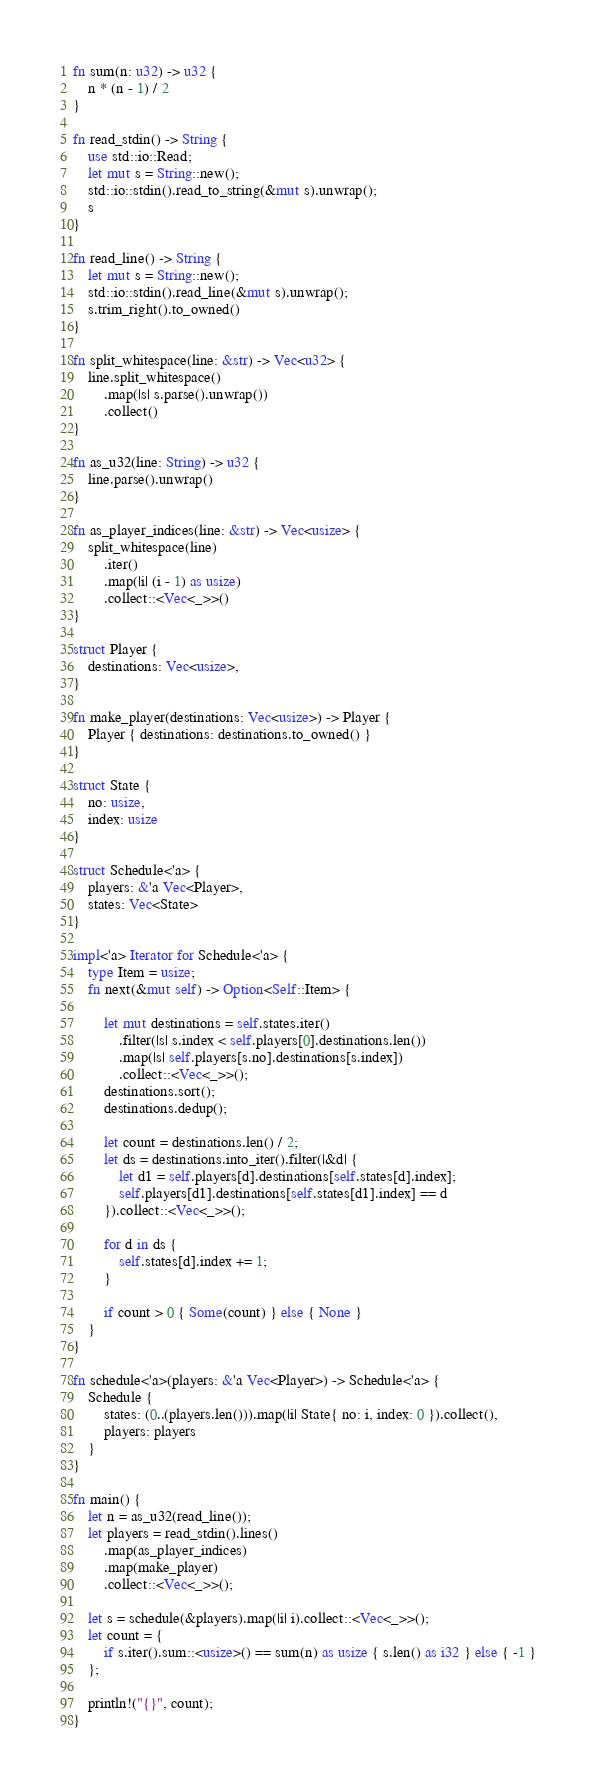<code> <loc_0><loc_0><loc_500><loc_500><_Rust_>fn sum(n: u32) -> u32 {
    n * (n - 1) / 2
}

fn read_stdin() -> String {
    use std::io::Read;
    let mut s = String::new();
    std::io::stdin().read_to_string(&mut s).unwrap();
    s
}

fn read_line() -> String {
    let mut s = String::new();
    std::io::stdin().read_line(&mut s).unwrap();
    s.trim_right().to_owned()
}

fn split_whitespace(line: &str) -> Vec<u32> {
    line.split_whitespace()
        .map(|s| s.parse().unwrap())
        .collect()
}

fn as_u32(line: String) -> u32 {
    line.parse().unwrap()
}

fn as_player_indices(line: &str) -> Vec<usize> {
    split_whitespace(line)
        .iter()
        .map(|i| (i - 1) as usize)
        .collect::<Vec<_>>()
}

struct Player {
    destinations: Vec<usize>,
}

fn make_player(destinations: Vec<usize>) -> Player {
    Player { destinations: destinations.to_owned() }
}

struct State {
    no: usize,
    index: usize
}

struct Schedule<'a> {
    players: &'a Vec<Player>,
    states: Vec<State>
}

impl<'a> Iterator for Schedule<'a> {
    type Item = usize;
    fn next(&mut self) -> Option<Self::Item> {
        
        let mut destinations = self.states.iter()
            .filter(|s| s.index < self.players[0].destinations.len())
            .map(|s| self.players[s.no].destinations[s.index])
            .collect::<Vec<_>>();
        destinations.sort();
        destinations.dedup();
            
        let count = destinations.len() / 2;
        let ds = destinations.into_iter().filter(|&d| {
            let d1 = self.players[d].destinations[self.states[d].index];
            self.players[d1].destinations[self.states[d1].index] == d
        }).collect::<Vec<_>>();
        
        for d in ds {
            self.states[d].index += 1;
        }
        
        if count > 0 { Some(count) } else { None }
    }
}

fn schedule<'a>(players: &'a Vec<Player>) -> Schedule<'a> {
    Schedule {
        states: (0..(players.len())).map(|i| State{ no: i, index: 0 }).collect(),
        players: players
    }
}

fn main() {
    let n = as_u32(read_line());
    let players = read_stdin().lines()
        .map(as_player_indices)
        .map(make_player)
        .collect::<Vec<_>>();
        
    let s = schedule(&players).map(|i| i).collect::<Vec<_>>();
    let count = {
        if s.iter().sum::<usize>() == sum(n) as usize { s.len() as i32 } else { -1 }
    };

    println!("{}", count);
}</code> 